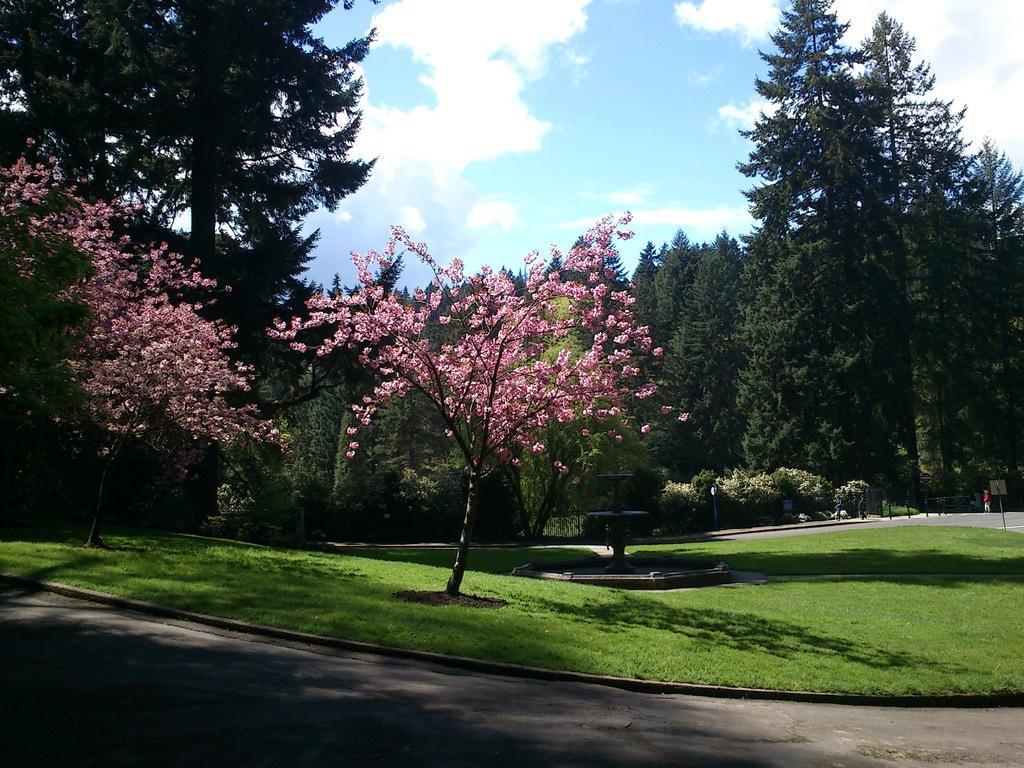Can you describe this image briefly? In this picture, we can see road, ground with grass, and we can see trees, poles, and the sky with clouds. 